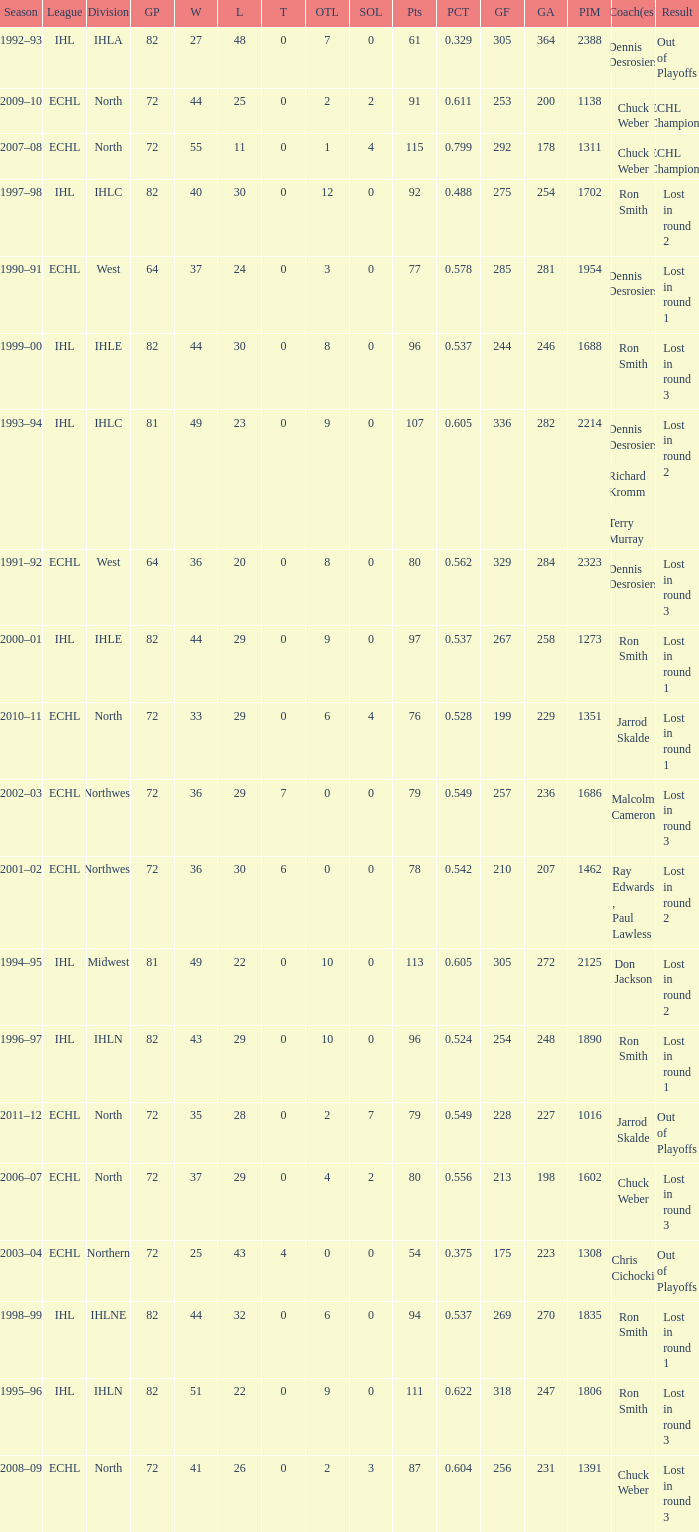How many season did the team lost in round 1 with a GP of 64? 1.0. 